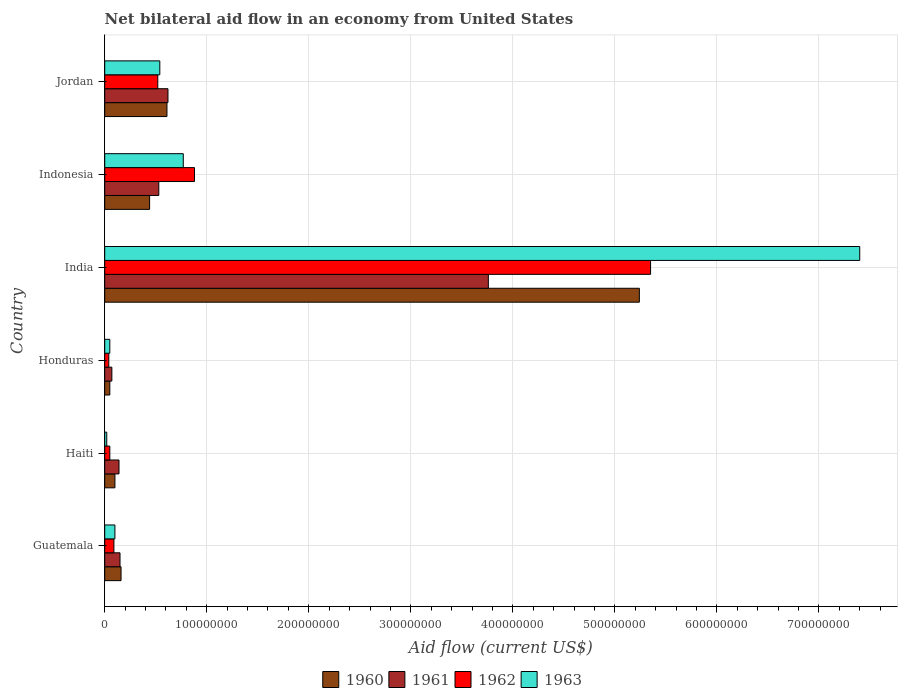Are the number of bars per tick equal to the number of legend labels?
Give a very brief answer. Yes. How many bars are there on the 6th tick from the top?
Provide a short and direct response. 4. What is the label of the 6th group of bars from the top?
Keep it short and to the point. Guatemala. In how many cases, is the number of bars for a given country not equal to the number of legend labels?
Your response must be concise. 0. What is the net bilateral aid flow in 1961 in Guatemala?
Provide a short and direct response. 1.50e+07. Across all countries, what is the maximum net bilateral aid flow in 1963?
Your answer should be compact. 7.40e+08. In which country was the net bilateral aid flow in 1963 minimum?
Offer a terse response. Haiti. What is the total net bilateral aid flow in 1960 in the graph?
Keep it short and to the point. 6.60e+08. What is the difference between the net bilateral aid flow in 1963 in Guatemala and that in Honduras?
Your response must be concise. 5.00e+06. What is the difference between the net bilateral aid flow in 1961 in India and the net bilateral aid flow in 1960 in Indonesia?
Make the answer very short. 3.32e+08. What is the average net bilateral aid flow in 1963 per country?
Make the answer very short. 1.48e+08. What is the difference between the net bilateral aid flow in 1960 and net bilateral aid flow in 1962 in Indonesia?
Offer a very short reply. -4.40e+07. In how many countries, is the net bilateral aid flow in 1963 greater than 640000000 US$?
Offer a very short reply. 1. What is the ratio of the net bilateral aid flow in 1961 in Honduras to that in India?
Your response must be concise. 0.02. Is the net bilateral aid flow in 1961 in Haiti less than that in Indonesia?
Your response must be concise. Yes. Is the difference between the net bilateral aid flow in 1960 in Haiti and India greater than the difference between the net bilateral aid flow in 1962 in Haiti and India?
Your answer should be very brief. Yes. What is the difference between the highest and the second highest net bilateral aid flow in 1962?
Ensure brevity in your answer.  4.47e+08. What is the difference between the highest and the lowest net bilateral aid flow in 1961?
Your response must be concise. 3.69e+08. In how many countries, is the net bilateral aid flow in 1961 greater than the average net bilateral aid flow in 1961 taken over all countries?
Provide a short and direct response. 1. Is the sum of the net bilateral aid flow in 1962 in Guatemala and Haiti greater than the maximum net bilateral aid flow in 1961 across all countries?
Ensure brevity in your answer.  No. Is it the case that in every country, the sum of the net bilateral aid flow in 1962 and net bilateral aid flow in 1961 is greater than the sum of net bilateral aid flow in 1963 and net bilateral aid flow in 1960?
Your answer should be compact. No. How many bars are there?
Your answer should be very brief. 24. Are all the bars in the graph horizontal?
Make the answer very short. Yes. How many countries are there in the graph?
Provide a succinct answer. 6. What is the difference between two consecutive major ticks on the X-axis?
Offer a terse response. 1.00e+08. Does the graph contain grids?
Provide a succinct answer. Yes. Where does the legend appear in the graph?
Your response must be concise. Bottom center. How many legend labels are there?
Provide a short and direct response. 4. What is the title of the graph?
Offer a terse response. Net bilateral aid flow in an economy from United States. What is the Aid flow (current US$) of 1960 in Guatemala?
Give a very brief answer. 1.60e+07. What is the Aid flow (current US$) in 1961 in Guatemala?
Your response must be concise. 1.50e+07. What is the Aid flow (current US$) in 1962 in Guatemala?
Offer a very short reply. 9.00e+06. What is the Aid flow (current US$) of 1960 in Haiti?
Provide a succinct answer. 1.00e+07. What is the Aid flow (current US$) in 1961 in Haiti?
Your answer should be compact. 1.40e+07. What is the Aid flow (current US$) of 1961 in Honduras?
Provide a short and direct response. 7.00e+06. What is the Aid flow (current US$) of 1962 in Honduras?
Give a very brief answer. 4.00e+06. What is the Aid flow (current US$) of 1963 in Honduras?
Offer a terse response. 5.00e+06. What is the Aid flow (current US$) of 1960 in India?
Offer a very short reply. 5.24e+08. What is the Aid flow (current US$) in 1961 in India?
Offer a terse response. 3.76e+08. What is the Aid flow (current US$) in 1962 in India?
Your answer should be compact. 5.35e+08. What is the Aid flow (current US$) in 1963 in India?
Make the answer very short. 7.40e+08. What is the Aid flow (current US$) of 1960 in Indonesia?
Provide a succinct answer. 4.40e+07. What is the Aid flow (current US$) of 1961 in Indonesia?
Your answer should be compact. 5.30e+07. What is the Aid flow (current US$) in 1962 in Indonesia?
Ensure brevity in your answer.  8.80e+07. What is the Aid flow (current US$) in 1963 in Indonesia?
Offer a terse response. 7.70e+07. What is the Aid flow (current US$) of 1960 in Jordan?
Give a very brief answer. 6.10e+07. What is the Aid flow (current US$) of 1961 in Jordan?
Offer a terse response. 6.20e+07. What is the Aid flow (current US$) in 1962 in Jordan?
Offer a terse response. 5.20e+07. What is the Aid flow (current US$) in 1963 in Jordan?
Your answer should be very brief. 5.40e+07. Across all countries, what is the maximum Aid flow (current US$) of 1960?
Your answer should be very brief. 5.24e+08. Across all countries, what is the maximum Aid flow (current US$) of 1961?
Provide a succinct answer. 3.76e+08. Across all countries, what is the maximum Aid flow (current US$) in 1962?
Your response must be concise. 5.35e+08. Across all countries, what is the maximum Aid flow (current US$) in 1963?
Provide a succinct answer. 7.40e+08. Across all countries, what is the minimum Aid flow (current US$) in 1961?
Provide a succinct answer. 7.00e+06. Across all countries, what is the minimum Aid flow (current US$) of 1962?
Keep it short and to the point. 4.00e+06. Across all countries, what is the minimum Aid flow (current US$) in 1963?
Ensure brevity in your answer.  2.00e+06. What is the total Aid flow (current US$) of 1960 in the graph?
Offer a very short reply. 6.60e+08. What is the total Aid flow (current US$) in 1961 in the graph?
Make the answer very short. 5.27e+08. What is the total Aid flow (current US$) in 1962 in the graph?
Your response must be concise. 6.93e+08. What is the total Aid flow (current US$) of 1963 in the graph?
Make the answer very short. 8.88e+08. What is the difference between the Aid flow (current US$) in 1960 in Guatemala and that in Haiti?
Offer a very short reply. 6.00e+06. What is the difference between the Aid flow (current US$) of 1961 in Guatemala and that in Haiti?
Your response must be concise. 1.00e+06. What is the difference between the Aid flow (current US$) in 1960 in Guatemala and that in Honduras?
Your answer should be very brief. 1.10e+07. What is the difference between the Aid flow (current US$) in 1961 in Guatemala and that in Honduras?
Offer a very short reply. 8.00e+06. What is the difference between the Aid flow (current US$) in 1960 in Guatemala and that in India?
Provide a succinct answer. -5.08e+08. What is the difference between the Aid flow (current US$) of 1961 in Guatemala and that in India?
Provide a short and direct response. -3.61e+08. What is the difference between the Aid flow (current US$) in 1962 in Guatemala and that in India?
Provide a short and direct response. -5.26e+08. What is the difference between the Aid flow (current US$) in 1963 in Guatemala and that in India?
Your answer should be very brief. -7.30e+08. What is the difference between the Aid flow (current US$) of 1960 in Guatemala and that in Indonesia?
Keep it short and to the point. -2.80e+07. What is the difference between the Aid flow (current US$) of 1961 in Guatemala and that in Indonesia?
Give a very brief answer. -3.80e+07. What is the difference between the Aid flow (current US$) in 1962 in Guatemala and that in Indonesia?
Give a very brief answer. -7.90e+07. What is the difference between the Aid flow (current US$) in 1963 in Guatemala and that in Indonesia?
Keep it short and to the point. -6.70e+07. What is the difference between the Aid flow (current US$) of 1960 in Guatemala and that in Jordan?
Give a very brief answer. -4.50e+07. What is the difference between the Aid flow (current US$) in 1961 in Guatemala and that in Jordan?
Keep it short and to the point. -4.70e+07. What is the difference between the Aid flow (current US$) in 1962 in Guatemala and that in Jordan?
Provide a succinct answer. -4.30e+07. What is the difference between the Aid flow (current US$) of 1963 in Guatemala and that in Jordan?
Offer a terse response. -4.40e+07. What is the difference between the Aid flow (current US$) of 1960 in Haiti and that in Honduras?
Ensure brevity in your answer.  5.00e+06. What is the difference between the Aid flow (current US$) of 1962 in Haiti and that in Honduras?
Make the answer very short. 1.00e+06. What is the difference between the Aid flow (current US$) in 1963 in Haiti and that in Honduras?
Keep it short and to the point. -3.00e+06. What is the difference between the Aid flow (current US$) of 1960 in Haiti and that in India?
Keep it short and to the point. -5.14e+08. What is the difference between the Aid flow (current US$) in 1961 in Haiti and that in India?
Offer a terse response. -3.62e+08. What is the difference between the Aid flow (current US$) of 1962 in Haiti and that in India?
Offer a terse response. -5.30e+08. What is the difference between the Aid flow (current US$) of 1963 in Haiti and that in India?
Your response must be concise. -7.38e+08. What is the difference between the Aid flow (current US$) of 1960 in Haiti and that in Indonesia?
Your answer should be very brief. -3.40e+07. What is the difference between the Aid flow (current US$) of 1961 in Haiti and that in Indonesia?
Your response must be concise. -3.90e+07. What is the difference between the Aid flow (current US$) in 1962 in Haiti and that in Indonesia?
Offer a very short reply. -8.30e+07. What is the difference between the Aid flow (current US$) of 1963 in Haiti and that in Indonesia?
Offer a very short reply. -7.50e+07. What is the difference between the Aid flow (current US$) in 1960 in Haiti and that in Jordan?
Your response must be concise. -5.10e+07. What is the difference between the Aid flow (current US$) in 1961 in Haiti and that in Jordan?
Give a very brief answer. -4.80e+07. What is the difference between the Aid flow (current US$) in 1962 in Haiti and that in Jordan?
Offer a very short reply. -4.70e+07. What is the difference between the Aid flow (current US$) of 1963 in Haiti and that in Jordan?
Your response must be concise. -5.20e+07. What is the difference between the Aid flow (current US$) in 1960 in Honduras and that in India?
Offer a terse response. -5.19e+08. What is the difference between the Aid flow (current US$) in 1961 in Honduras and that in India?
Offer a terse response. -3.69e+08. What is the difference between the Aid flow (current US$) of 1962 in Honduras and that in India?
Your response must be concise. -5.31e+08. What is the difference between the Aid flow (current US$) of 1963 in Honduras and that in India?
Your response must be concise. -7.35e+08. What is the difference between the Aid flow (current US$) in 1960 in Honduras and that in Indonesia?
Offer a terse response. -3.90e+07. What is the difference between the Aid flow (current US$) of 1961 in Honduras and that in Indonesia?
Your response must be concise. -4.60e+07. What is the difference between the Aid flow (current US$) of 1962 in Honduras and that in Indonesia?
Provide a succinct answer. -8.40e+07. What is the difference between the Aid flow (current US$) of 1963 in Honduras and that in Indonesia?
Offer a very short reply. -7.20e+07. What is the difference between the Aid flow (current US$) in 1960 in Honduras and that in Jordan?
Ensure brevity in your answer.  -5.60e+07. What is the difference between the Aid flow (current US$) in 1961 in Honduras and that in Jordan?
Your answer should be compact. -5.50e+07. What is the difference between the Aid flow (current US$) in 1962 in Honduras and that in Jordan?
Make the answer very short. -4.80e+07. What is the difference between the Aid flow (current US$) in 1963 in Honduras and that in Jordan?
Give a very brief answer. -4.90e+07. What is the difference between the Aid flow (current US$) of 1960 in India and that in Indonesia?
Your answer should be very brief. 4.80e+08. What is the difference between the Aid flow (current US$) of 1961 in India and that in Indonesia?
Your response must be concise. 3.23e+08. What is the difference between the Aid flow (current US$) in 1962 in India and that in Indonesia?
Offer a very short reply. 4.47e+08. What is the difference between the Aid flow (current US$) in 1963 in India and that in Indonesia?
Offer a terse response. 6.63e+08. What is the difference between the Aid flow (current US$) of 1960 in India and that in Jordan?
Provide a short and direct response. 4.63e+08. What is the difference between the Aid flow (current US$) of 1961 in India and that in Jordan?
Ensure brevity in your answer.  3.14e+08. What is the difference between the Aid flow (current US$) in 1962 in India and that in Jordan?
Provide a short and direct response. 4.83e+08. What is the difference between the Aid flow (current US$) in 1963 in India and that in Jordan?
Your answer should be very brief. 6.86e+08. What is the difference between the Aid flow (current US$) in 1960 in Indonesia and that in Jordan?
Make the answer very short. -1.70e+07. What is the difference between the Aid flow (current US$) of 1961 in Indonesia and that in Jordan?
Make the answer very short. -9.00e+06. What is the difference between the Aid flow (current US$) of 1962 in Indonesia and that in Jordan?
Provide a short and direct response. 3.60e+07. What is the difference between the Aid flow (current US$) of 1963 in Indonesia and that in Jordan?
Your answer should be compact. 2.30e+07. What is the difference between the Aid flow (current US$) of 1960 in Guatemala and the Aid flow (current US$) of 1962 in Haiti?
Offer a very short reply. 1.10e+07. What is the difference between the Aid flow (current US$) in 1960 in Guatemala and the Aid flow (current US$) in 1963 in Haiti?
Keep it short and to the point. 1.40e+07. What is the difference between the Aid flow (current US$) of 1961 in Guatemala and the Aid flow (current US$) of 1962 in Haiti?
Your response must be concise. 1.00e+07. What is the difference between the Aid flow (current US$) of 1961 in Guatemala and the Aid flow (current US$) of 1963 in Haiti?
Give a very brief answer. 1.30e+07. What is the difference between the Aid flow (current US$) in 1960 in Guatemala and the Aid flow (current US$) in 1961 in Honduras?
Offer a very short reply. 9.00e+06. What is the difference between the Aid flow (current US$) in 1960 in Guatemala and the Aid flow (current US$) in 1962 in Honduras?
Your response must be concise. 1.20e+07. What is the difference between the Aid flow (current US$) of 1960 in Guatemala and the Aid flow (current US$) of 1963 in Honduras?
Make the answer very short. 1.10e+07. What is the difference between the Aid flow (current US$) in 1961 in Guatemala and the Aid flow (current US$) in 1962 in Honduras?
Your answer should be very brief. 1.10e+07. What is the difference between the Aid flow (current US$) in 1962 in Guatemala and the Aid flow (current US$) in 1963 in Honduras?
Make the answer very short. 4.00e+06. What is the difference between the Aid flow (current US$) in 1960 in Guatemala and the Aid flow (current US$) in 1961 in India?
Your answer should be compact. -3.60e+08. What is the difference between the Aid flow (current US$) of 1960 in Guatemala and the Aid flow (current US$) of 1962 in India?
Keep it short and to the point. -5.19e+08. What is the difference between the Aid flow (current US$) in 1960 in Guatemala and the Aid flow (current US$) in 1963 in India?
Your answer should be compact. -7.24e+08. What is the difference between the Aid flow (current US$) in 1961 in Guatemala and the Aid flow (current US$) in 1962 in India?
Provide a short and direct response. -5.20e+08. What is the difference between the Aid flow (current US$) of 1961 in Guatemala and the Aid flow (current US$) of 1963 in India?
Provide a succinct answer. -7.25e+08. What is the difference between the Aid flow (current US$) of 1962 in Guatemala and the Aid flow (current US$) of 1963 in India?
Your answer should be compact. -7.31e+08. What is the difference between the Aid flow (current US$) of 1960 in Guatemala and the Aid flow (current US$) of 1961 in Indonesia?
Keep it short and to the point. -3.70e+07. What is the difference between the Aid flow (current US$) in 1960 in Guatemala and the Aid flow (current US$) in 1962 in Indonesia?
Keep it short and to the point. -7.20e+07. What is the difference between the Aid flow (current US$) in 1960 in Guatemala and the Aid flow (current US$) in 1963 in Indonesia?
Give a very brief answer. -6.10e+07. What is the difference between the Aid flow (current US$) of 1961 in Guatemala and the Aid flow (current US$) of 1962 in Indonesia?
Make the answer very short. -7.30e+07. What is the difference between the Aid flow (current US$) in 1961 in Guatemala and the Aid flow (current US$) in 1963 in Indonesia?
Give a very brief answer. -6.20e+07. What is the difference between the Aid flow (current US$) in 1962 in Guatemala and the Aid flow (current US$) in 1963 in Indonesia?
Keep it short and to the point. -6.80e+07. What is the difference between the Aid flow (current US$) of 1960 in Guatemala and the Aid flow (current US$) of 1961 in Jordan?
Ensure brevity in your answer.  -4.60e+07. What is the difference between the Aid flow (current US$) of 1960 in Guatemala and the Aid flow (current US$) of 1962 in Jordan?
Your answer should be very brief. -3.60e+07. What is the difference between the Aid flow (current US$) in 1960 in Guatemala and the Aid flow (current US$) in 1963 in Jordan?
Ensure brevity in your answer.  -3.80e+07. What is the difference between the Aid flow (current US$) in 1961 in Guatemala and the Aid flow (current US$) in 1962 in Jordan?
Give a very brief answer. -3.70e+07. What is the difference between the Aid flow (current US$) in 1961 in Guatemala and the Aid flow (current US$) in 1963 in Jordan?
Make the answer very short. -3.90e+07. What is the difference between the Aid flow (current US$) in 1962 in Guatemala and the Aid flow (current US$) in 1963 in Jordan?
Offer a terse response. -4.50e+07. What is the difference between the Aid flow (current US$) of 1960 in Haiti and the Aid flow (current US$) of 1962 in Honduras?
Provide a short and direct response. 6.00e+06. What is the difference between the Aid flow (current US$) of 1961 in Haiti and the Aid flow (current US$) of 1962 in Honduras?
Your answer should be compact. 1.00e+07. What is the difference between the Aid flow (current US$) of 1961 in Haiti and the Aid flow (current US$) of 1963 in Honduras?
Provide a succinct answer. 9.00e+06. What is the difference between the Aid flow (current US$) of 1960 in Haiti and the Aid flow (current US$) of 1961 in India?
Offer a very short reply. -3.66e+08. What is the difference between the Aid flow (current US$) of 1960 in Haiti and the Aid flow (current US$) of 1962 in India?
Give a very brief answer. -5.25e+08. What is the difference between the Aid flow (current US$) in 1960 in Haiti and the Aid flow (current US$) in 1963 in India?
Your answer should be compact. -7.30e+08. What is the difference between the Aid flow (current US$) in 1961 in Haiti and the Aid flow (current US$) in 1962 in India?
Your response must be concise. -5.21e+08. What is the difference between the Aid flow (current US$) of 1961 in Haiti and the Aid flow (current US$) of 1963 in India?
Make the answer very short. -7.26e+08. What is the difference between the Aid flow (current US$) in 1962 in Haiti and the Aid flow (current US$) in 1963 in India?
Provide a succinct answer. -7.35e+08. What is the difference between the Aid flow (current US$) in 1960 in Haiti and the Aid flow (current US$) in 1961 in Indonesia?
Your answer should be compact. -4.30e+07. What is the difference between the Aid flow (current US$) in 1960 in Haiti and the Aid flow (current US$) in 1962 in Indonesia?
Give a very brief answer. -7.80e+07. What is the difference between the Aid flow (current US$) in 1960 in Haiti and the Aid flow (current US$) in 1963 in Indonesia?
Provide a short and direct response. -6.70e+07. What is the difference between the Aid flow (current US$) of 1961 in Haiti and the Aid flow (current US$) of 1962 in Indonesia?
Give a very brief answer. -7.40e+07. What is the difference between the Aid flow (current US$) in 1961 in Haiti and the Aid flow (current US$) in 1963 in Indonesia?
Provide a short and direct response. -6.30e+07. What is the difference between the Aid flow (current US$) in 1962 in Haiti and the Aid flow (current US$) in 1963 in Indonesia?
Give a very brief answer. -7.20e+07. What is the difference between the Aid flow (current US$) in 1960 in Haiti and the Aid flow (current US$) in 1961 in Jordan?
Your response must be concise. -5.20e+07. What is the difference between the Aid flow (current US$) in 1960 in Haiti and the Aid flow (current US$) in 1962 in Jordan?
Offer a terse response. -4.20e+07. What is the difference between the Aid flow (current US$) in 1960 in Haiti and the Aid flow (current US$) in 1963 in Jordan?
Provide a succinct answer. -4.40e+07. What is the difference between the Aid flow (current US$) in 1961 in Haiti and the Aid flow (current US$) in 1962 in Jordan?
Offer a very short reply. -3.80e+07. What is the difference between the Aid flow (current US$) of 1961 in Haiti and the Aid flow (current US$) of 1963 in Jordan?
Ensure brevity in your answer.  -4.00e+07. What is the difference between the Aid flow (current US$) of 1962 in Haiti and the Aid flow (current US$) of 1963 in Jordan?
Provide a succinct answer. -4.90e+07. What is the difference between the Aid flow (current US$) in 1960 in Honduras and the Aid flow (current US$) in 1961 in India?
Your answer should be compact. -3.71e+08. What is the difference between the Aid flow (current US$) of 1960 in Honduras and the Aid flow (current US$) of 1962 in India?
Keep it short and to the point. -5.30e+08. What is the difference between the Aid flow (current US$) of 1960 in Honduras and the Aid flow (current US$) of 1963 in India?
Provide a succinct answer. -7.35e+08. What is the difference between the Aid flow (current US$) of 1961 in Honduras and the Aid flow (current US$) of 1962 in India?
Offer a terse response. -5.28e+08. What is the difference between the Aid flow (current US$) in 1961 in Honduras and the Aid flow (current US$) in 1963 in India?
Offer a terse response. -7.33e+08. What is the difference between the Aid flow (current US$) of 1962 in Honduras and the Aid flow (current US$) of 1963 in India?
Your response must be concise. -7.36e+08. What is the difference between the Aid flow (current US$) in 1960 in Honduras and the Aid flow (current US$) in 1961 in Indonesia?
Offer a terse response. -4.80e+07. What is the difference between the Aid flow (current US$) of 1960 in Honduras and the Aid flow (current US$) of 1962 in Indonesia?
Ensure brevity in your answer.  -8.30e+07. What is the difference between the Aid flow (current US$) of 1960 in Honduras and the Aid flow (current US$) of 1963 in Indonesia?
Give a very brief answer. -7.20e+07. What is the difference between the Aid flow (current US$) of 1961 in Honduras and the Aid flow (current US$) of 1962 in Indonesia?
Offer a very short reply. -8.10e+07. What is the difference between the Aid flow (current US$) in 1961 in Honduras and the Aid flow (current US$) in 1963 in Indonesia?
Offer a terse response. -7.00e+07. What is the difference between the Aid flow (current US$) in 1962 in Honduras and the Aid flow (current US$) in 1963 in Indonesia?
Your response must be concise. -7.30e+07. What is the difference between the Aid flow (current US$) of 1960 in Honduras and the Aid flow (current US$) of 1961 in Jordan?
Provide a short and direct response. -5.70e+07. What is the difference between the Aid flow (current US$) of 1960 in Honduras and the Aid flow (current US$) of 1962 in Jordan?
Your answer should be very brief. -4.70e+07. What is the difference between the Aid flow (current US$) of 1960 in Honduras and the Aid flow (current US$) of 1963 in Jordan?
Offer a very short reply. -4.90e+07. What is the difference between the Aid flow (current US$) of 1961 in Honduras and the Aid flow (current US$) of 1962 in Jordan?
Provide a short and direct response. -4.50e+07. What is the difference between the Aid flow (current US$) in 1961 in Honduras and the Aid flow (current US$) in 1963 in Jordan?
Keep it short and to the point. -4.70e+07. What is the difference between the Aid flow (current US$) of 1962 in Honduras and the Aid flow (current US$) of 1963 in Jordan?
Your answer should be compact. -5.00e+07. What is the difference between the Aid flow (current US$) of 1960 in India and the Aid flow (current US$) of 1961 in Indonesia?
Ensure brevity in your answer.  4.71e+08. What is the difference between the Aid flow (current US$) in 1960 in India and the Aid flow (current US$) in 1962 in Indonesia?
Keep it short and to the point. 4.36e+08. What is the difference between the Aid flow (current US$) in 1960 in India and the Aid flow (current US$) in 1963 in Indonesia?
Provide a succinct answer. 4.47e+08. What is the difference between the Aid flow (current US$) in 1961 in India and the Aid flow (current US$) in 1962 in Indonesia?
Make the answer very short. 2.88e+08. What is the difference between the Aid flow (current US$) of 1961 in India and the Aid flow (current US$) of 1963 in Indonesia?
Give a very brief answer. 2.99e+08. What is the difference between the Aid flow (current US$) of 1962 in India and the Aid flow (current US$) of 1963 in Indonesia?
Keep it short and to the point. 4.58e+08. What is the difference between the Aid flow (current US$) of 1960 in India and the Aid flow (current US$) of 1961 in Jordan?
Ensure brevity in your answer.  4.62e+08. What is the difference between the Aid flow (current US$) of 1960 in India and the Aid flow (current US$) of 1962 in Jordan?
Your answer should be very brief. 4.72e+08. What is the difference between the Aid flow (current US$) of 1960 in India and the Aid flow (current US$) of 1963 in Jordan?
Make the answer very short. 4.70e+08. What is the difference between the Aid flow (current US$) in 1961 in India and the Aid flow (current US$) in 1962 in Jordan?
Your response must be concise. 3.24e+08. What is the difference between the Aid flow (current US$) in 1961 in India and the Aid flow (current US$) in 1963 in Jordan?
Provide a short and direct response. 3.22e+08. What is the difference between the Aid flow (current US$) of 1962 in India and the Aid flow (current US$) of 1963 in Jordan?
Your answer should be very brief. 4.81e+08. What is the difference between the Aid flow (current US$) in 1960 in Indonesia and the Aid flow (current US$) in 1961 in Jordan?
Your answer should be compact. -1.80e+07. What is the difference between the Aid flow (current US$) of 1960 in Indonesia and the Aid flow (current US$) of 1962 in Jordan?
Offer a very short reply. -8.00e+06. What is the difference between the Aid flow (current US$) of 1960 in Indonesia and the Aid flow (current US$) of 1963 in Jordan?
Your answer should be compact. -1.00e+07. What is the difference between the Aid flow (current US$) of 1962 in Indonesia and the Aid flow (current US$) of 1963 in Jordan?
Your answer should be very brief. 3.40e+07. What is the average Aid flow (current US$) of 1960 per country?
Keep it short and to the point. 1.10e+08. What is the average Aid flow (current US$) of 1961 per country?
Your response must be concise. 8.78e+07. What is the average Aid flow (current US$) in 1962 per country?
Your answer should be compact. 1.16e+08. What is the average Aid flow (current US$) in 1963 per country?
Offer a very short reply. 1.48e+08. What is the difference between the Aid flow (current US$) in 1960 and Aid flow (current US$) in 1961 in Guatemala?
Ensure brevity in your answer.  1.00e+06. What is the difference between the Aid flow (current US$) of 1960 and Aid flow (current US$) of 1962 in Guatemala?
Keep it short and to the point. 7.00e+06. What is the difference between the Aid flow (current US$) in 1960 and Aid flow (current US$) in 1963 in Guatemala?
Your answer should be compact. 6.00e+06. What is the difference between the Aid flow (current US$) of 1961 and Aid flow (current US$) of 1962 in Guatemala?
Offer a very short reply. 6.00e+06. What is the difference between the Aid flow (current US$) in 1962 and Aid flow (current US$) in 1963 in Guatemala?
Offer a terse response. -1.00e+06. What is the difference between the Aid flow (current US$) of 1960 and Aid flow (current US$) of 1963 in Haiti?
Provide a succinct answer. 8.00e+06. What is the difference between the Aid flow (current US$) in 1961 and Aid flow (current US$) in 1962 in Haiti?
Your answer should be very brief. 9.00e+06. What is the difference between the Aid flow (current US$) of 1961 and Aid flow (current US$) of 1963 in Haiti?
Your answer should be very brief. 1.20e+07. What is the difference between the Aid flow (current US$) of 1962 and Aid flow (current US$) of 1963 in Haiti?
Provide a short and direct response. 3.00e+06. What is the difference between the Aid flow (current US$) in 1960 and Aid flow (current US$) in 1962 in Honduras?
Keep it short and to the point. 1.00e+06. What is the difference between the Aid flow (current US$) in 1960 and Aid flow (current US$) in 1963 in Honduras?
Provide a short and direct response. 0. What is the difference between the Aid flow (current US$) in 1960 and Aid flow (current US$) in 1961 in India?
Offer a terse response. 1.48e+08. What is the difference between the Aid flow (current US$) in 1960 and Aid flow (current US$) in 1962 in India?
Give a very brief answer. -1.10e+07. What is the difference between the Aid flow (current US$) of 1960 and Aid flow (current US$) of 1963 in India?
Your response must be concise. -2.16e+08. What is the difference between the Aid flow (current US$) of 1961 and Aid flow (current US$) of 1962 in India?
Your answer should be compact. -1.59e+08. What is the difference between the Aid flow (current US$) of 1961 and Aid flow (current US$) of 1963 in India?
Your response must be concise. -3.64e+08. What is the difference between the Aid flow (current US$) of 1962 and Aid flow (current US$) of 1963 in India?
Provide a short and direct response. -2.05e+08. What is the difference between the Aid flow (current US$) in 1960 and Aid flow (current US$) in 1961 in Indonesia?
Provide a succinct answer. -9.00e+06. What is the difference between the Aid flow (current US$) in 1960 and Aid flow (current US$) in 1962 in Indonesia?
Your answer should be very brief. -4.40e+07. What is the difference between the Aid flow (current US$) of 1960 and Aid flow (current US$) of 1963 in Indonesia?
Offer a very short reply. -3.30e+07. What is the difference between the Aid flow (current US$) of 1961 and Aid flow (current US$) of 1962 in Indonesia?
Your answer should be compact. -3.50e+07. What is the difference between the Aid flow (current US$) in 1961 and Aid flow (current US$) in 1963 in Indonesia?
Give a very brief answer. -2.40e+07. What is the difference between the Aid flow (current US$) in 1962 and Aid flow (current US$) in 1963 in Indonesia?
Offer a very short reply. 1.10e+07. What is the difference between the Aid flow (current US$) of 1960 and Aid flow (current US$) of 1961 in Jordan?
Make the answer very short. -1.00e+06. What is the difference between the Aid flow (current US$) of 1960 and Aid flow (current US$) of 1962 in Jordan?
Your response must be concise. 9.00e+06. What is the difference between the Aid flow (current US$) in 1961 and Aid flow (current US$) in 1962 in Jordan?
Offer a terse response. 1.00e+07. What is the ratio of the Aid flow (current US$) in 1961 in Guatemala to that in Haiti?
Keep it short and to the point. 1.07. What is the ratio of the Aid flow (current US$) of 1963 in Guatemala to that in Haiti?
Offer a very short reply. 5. What is the ratio of the Aid flow (current US$) of 1961 in Guatemala to that in Honduras?
Your answer should be compact. 2.14. What is the ratio of the Aid flow (current US$) in 1962 in Guatemala to that in Honduras?
Give a very brief answer. 2.25. What is the ratio of the Aid flow (current US$) in 1960 in Guatemala to that in India?
Give a very brief answer. 0.03. What is the ratio of the Aid flow (current US$) in 1961 in Guatemala to that in India?
Keep it short and to the point. 0.04. What is the ratio of the Aid flow (current US$) of 1962 in Guatemala to that in India?
Your answer should be very brief. 0.02. What is the ratio of the Aid flow (current US$) in 1963 in Guatemala to that in India?
Offer a terse response. 0.01. What is the ratio of the Aid flow (current US$) of 1960 in Guatemala to that in Indonesia?
Provide a short and direct response. 0.36. What is the ratio of the Aid flow (current US$) in 1961 in Guatemala to that in Indonesia?
Provide a short and direct response. 0.28. What is the ratio of the Aid flow (current US$) in 1962 in Guatemala to that in Indonesia?
Offer a very short reply. 0.1. What is the ratio of the Aid flow (current US$) of 1963 in Guatemala to that in Indonesia?
Make the answer very short. 0.13. What is the ratio of the Aid flow (current US$) in 1960 in Guatemala to that in Jordan?
Keep it short and to the point. 0.26. What is the ratio of the Aid flow (current US$) of 1961 in Guatemala to that in Jordan?
Offer a terse response. 0.24. What is the ratio of the Aid flow (current US$) in 1962 in Guatemala to that in Jordan?
Provide a short and direct response. 0.17. What is the ratio of the Aid flow (current US$) of 1963 in Guatemala to that in Jordan?
Keep it short and to the point. 0.19. What is the ratio of the Aid flow (current US$) of 1960 in Haiti to that in Honduras?
Ensure brevity in your answer.  2. What is the ratio of the Aid flow (current US$) of 1962 in Haiti to that in Honduras?
Ensure brevity in your answer.  1.25. What is the ratio of the Aid flow (current US$) of 1963 in Haiti to that in Honduras?
Ensure brevity in your answer.  0.4. What is the ratio of the Aid flow (current US$) of 1960 in Haiti to that in India?
Give a very brief answer. 0.02. What is the ratio of the Aid flow (current US$) of 1961 in Haiti to that in India?
Give a very brief answer. 0.04. What is the ratio of the Aid flow (current US$) in 1962 in Haiti to that in India?
Offer a very short reply. 0.01. What is the ratio of the Aid flow (current US$) in 1963 in Haiti to that in India?
Keep it short and to the point. 0. What is the ratio of the Aid flow (current US$) of 1960 in Haiti to that in Indonesia?
Offer a terse response. 0.23. What is the ratio of the Aid flow (current US$) of 1961 in Haiti to that in Indonesia?
Your answer should be very brief. 0.26. What is the ratio of the Aid flow (current US$) of 1962 in Haiti to that in Indonesia?
Your response must be concise. 0.06. What is the ratio of the Aid flow (current US$) in 1963 in Haiti to that in Indonesia?
Keep it short and to the point. 0.03. What is the ratio of the Aid flow (current US$) of 1960 in Haiti to that in Jordan?
Your answer should be very brief. 0.16. What is the ratio of the Aid flow (current US$) in 1961 in Haiti to that in Jordan?
Offer a terse response. 0.23. What is the ratio of the Aid flow (current US$) of 1962 in Haiti to that in Jordan?
Provide a succinct answer. 0.1. What is the ratio of the Aid flow (current US$) of 1963 in Haiti to that in Jordan?
Give a very brief answer. 0.04. What is the ratio of the Aid flow (current US$) of 1960 in Honduras to that in India?
Make the answer very short. 0.01. What is the ratio of the Aid flow (current US$) of 1961 in Honduras to that in India?
Make the answer very short. 0.02. What is the ratio of the Aid flow (current US$) in 1962 in Honduras to that in India?
Provide a succinct answer. 0.01. What is the ratio of the Aid flow (current US$) in 1963 in Honduras to that in India?
Your answer should be compact. 0.01. What is the ratio of the Aid flow (current US$) of 1960 in Honduras to that in Indonesia?
Keep it short and to the point. 0.11. What is the ratio of the Aid flow (current US$) of 1961 in Honduras to that in Indonesia?
Offer a very short reply. 0.13. What is the ratio of the Aid flow (current US$) of 1962 in Honduras to that in Indonesia?
Offer a terse response. 0.05. What is the ratio of the Aid flow (current US$) in 1963 in Honduras to that in Indonesia?
Provide a succinct answer. 0.06. What is the ratio of the Aid flow (current US$) of 1960 in Honduras to that in Jordan?
Give a very brief answer. 0.08. What is the ratio of the Aid flow (current US$) in 1961 in Honduras to that in Jordan?
Make the answer very short. 0.11. What is the ratio of the Aid flow (current US$) in 1962 in Honduras to that in Jordan?
Offer a terse response. 0.08. What is the ratio of the Aid flow (current US$) of 1963 in Honduras to that in Jordan?
Your answer should be compact. 0.09. What is the ratio of the Aid flow (current US$) in 1960 in India to that in Indonesia?
Give a very brief answer. 11.91. What is the ratio of the Aid flow (current US$) of 1961 in India to that in Indonesia?
Give a very brief answer. 7.09. What is the ratio of the Aid flow (current US$) of 1962 in India to that in Indonesia?
Your answer should be compact. 6.08. What is the ratio of the Aid flow (current US$) of 1963 in India to that in Indonesia?
Provide a succinct answer. 9.61. What is the ratio of the Aid flow (current US$) in 1960 in India to that in Jordan?
Provide a short and direct response. 8.59. What is the ratio of the Aid flow (current US$) in 1961 in India to that in Jordan?
Ensure brevity in your answer.  6.06. What is the ratio of the Aid flow (current US$) in 1962 in India to that in Jordan?
Ensure brevity in your answer.  10.29. What is the ratio of the Aid flow (current US$) in 1963 in India to that in Jordan?
Give a very brief answer. 13.7. What is the ratio of the Aid flow (current US$) in 1960 in Indonesia to that in Jordan?
Offer a very short reply. 0.72. What is the ratio of the Aid flow (current US$) in 1961 in Indonesia to that in Jordan?
Your response must be concise. 0.85. What is the ratio of the Aid flow (current US$) in 1962 in Indonesia to that in Jordan?
Your answer should be compact. 1.69. What is the ratio of the Aid flow (current US$) in 1963 in Indonesia to that in Jordan?
Keep it short and to the point. 1.43. What is the difference between the highest and the second highest Aid flow (current US$) in 1960?
Offer a very short reply. 4.63e+08. What is the difference between the highest and the second highest Aid flow (current US$) of 1961?
Give a very brief answer. 3.14e+08. What is the difference between the highest and the second highest Aid flow (current US$) in 1962?
Your response must be concise. 4.47e+08. What is the difference between the highest and the second highest Aid flow (current US$) in 1963?
Provide a succinct answer. 6.63e+08. What is the difference between the highest and the lowest Aid flow (current US$) in 1960?
Provide a succinct answer. 5.19e+08. What is the difference between the highest and the lowest Aid flow (current US$) in 1961?
Give a very brief answer. 3.69e+08. What is the difference between the highest and the lowest Aid flow (current US$) in 1962?
Offer a very short reply. 5.31e+08. What is the difference between the highest and the lowest Aid flow (current US$) in 1963?
Provide a short and direct response. 7.38e+08. 